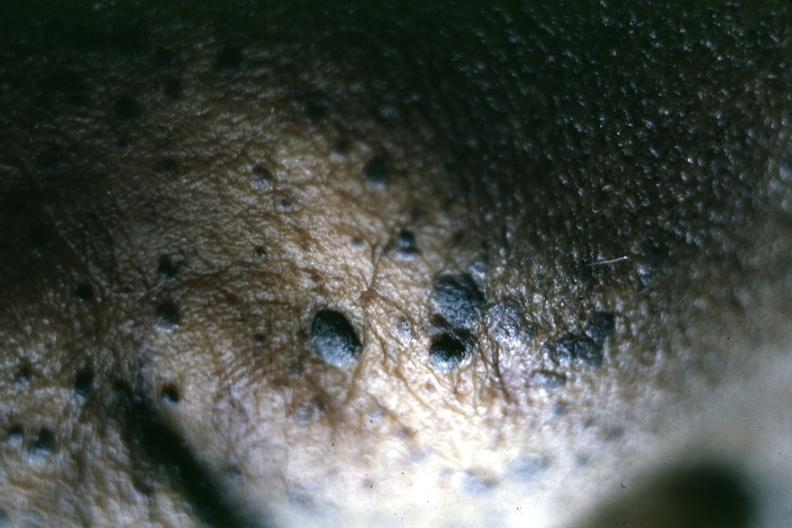where is this?
Answer the question using a single word or phrase. Skin 